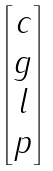Convert formula to latex. <formula><loc_0><loc_0><loc_500><loc_500>\begin{bmatrix} c \\ g \\ l \\ p \end{bmatrix}</formula> 